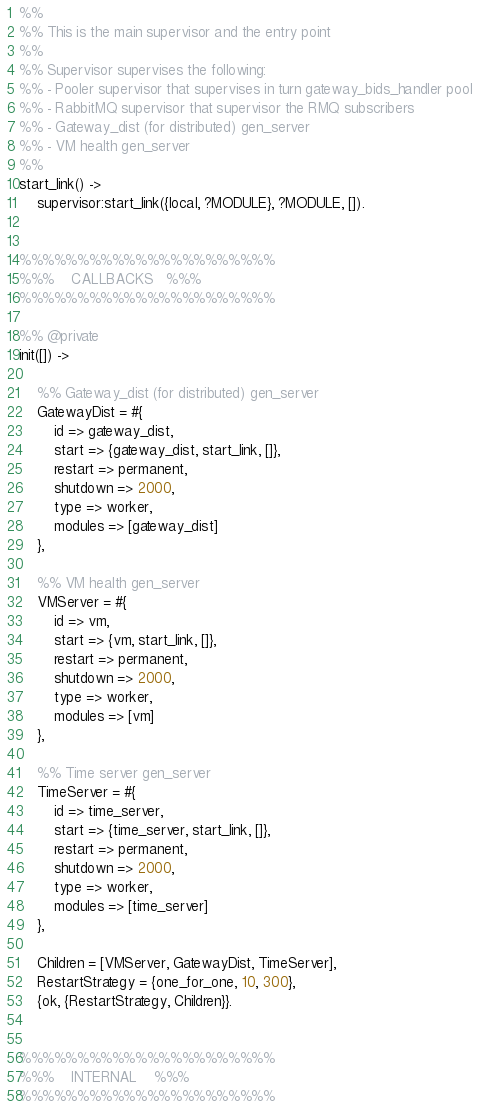Convert code to text. <code><loc_0><loc_0><loc_500><loc_500><_Erlang_>%%
%% This is the main supervisor and the entry point
%%
%% Supervisor supervises the following:
%% - Pooler supervisor that supervises in turn gateway_bids_handler pool
%% - RabbitMQ supervisor that supervisor the RMQ subscribers
%% - Gateway_dist (for distributed) gen_server
%% - VM health gen_server
%%
start_link() ->
	supervisor:start_link({local, ?MODULE}, ?MODULE, []).


%%%%%%%%%%%%%%%%%%%%%%
%%%    CALLBACKS   %%%
%%%%%%%%%%%%%%%%%%%%%%

%% @private
init([]) ->

	%% Gateway_dist (for distributed) gen_server
	GatewayDist = #{
		id => gateway_dist,
		start => {gateway_dist, start_link, []},
		restart => permanent,
		shutdown => 2000,
		type => worker,
		modules => [gateway_dist]
	},

	%% VM health gen_server
	VMServer = #{
		id => vm,
		start => {vm, start_link, []},
		restart => permanent,
		shutdown => 2000,
		type => worker,
		modules => [vm]
	},

	%% Time server gen_server
	TimeServer = #{
		id => time_server,
		start => {time_server, start_link, []},
		restart => permanent,
		shutdown => 2000,
		type => worker,
		modules => [time_server]
	},

	Children = [VMServer, GatewayDist, TimeServer],
	RestartStrategy = {one_for_one, 10, 300},
	{ok, {RestartStrategy, Children}}.


%%%%%%%%%%%%%%%%%%%%%%
%%%    INTERNAL    %%%
%%%%%%%%%%%%%%%%%%%%%%
</code> 